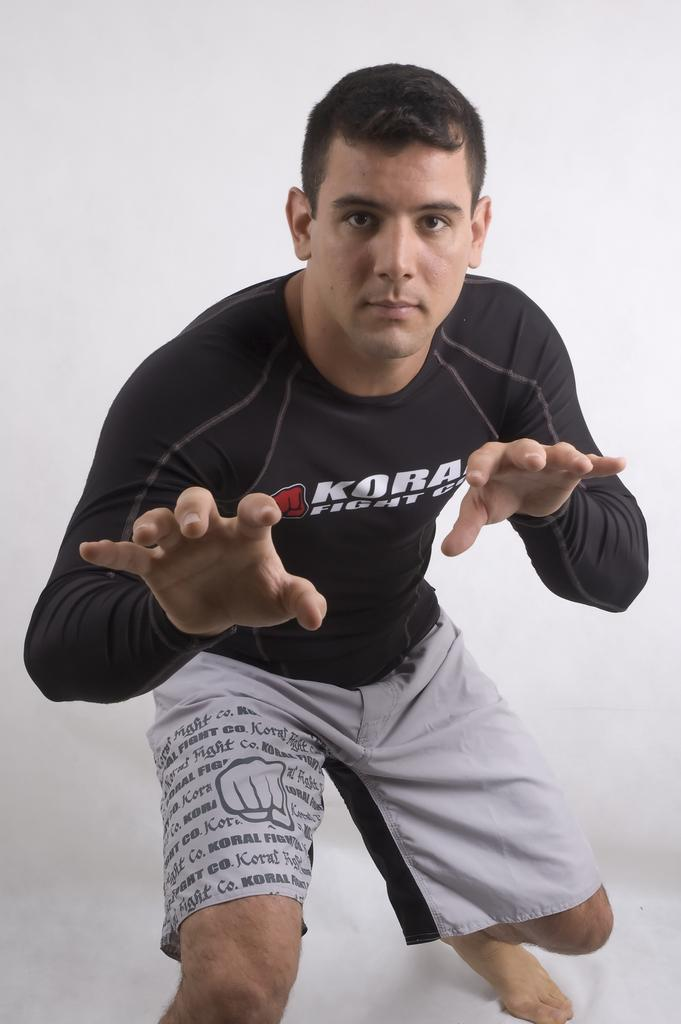Who is present in the image? There is a man in the image. What is the man wearing on his upper body? The man is wearing a black T-shirt. What is the man wearing on his lower body? The man is wearing grey shorts. What color is the background of the image? The background of the image is white. Are there any ants crawling on the man's hat in the image? There is no hat present in the image, and therefore no ants crawling on it. 